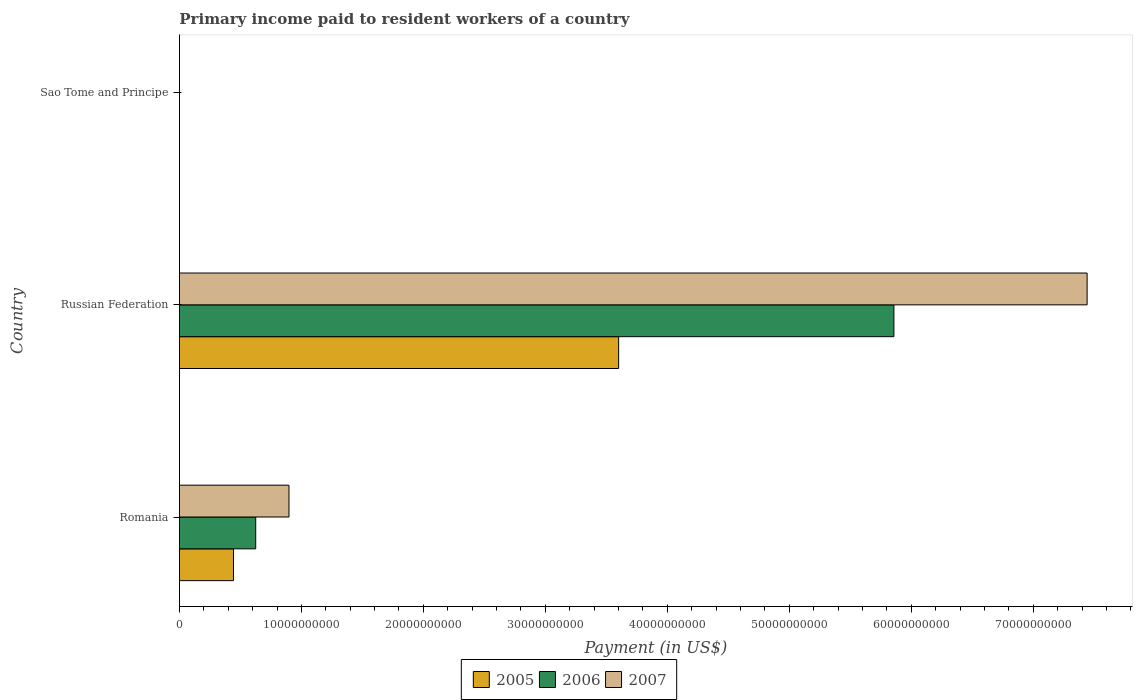Are the number of bars per tick equal to the number of legend labels?
Your response must be concise. Yes. How many bars are there on the 1st tick from the top?
Your answer should be very brief. 3. What is the label of the 3rd group of bars from the top?
Give a very brief answer. Romania. What is the amount paid to workers in 2006 in Russian Federation?
Keep it short and to the point. 5.86e+1. Across all countries, what is the maximum amount paid to workers in 2006?
Your answer should be compact. 5.86e+1. Across all countries, what is the minimum amount paid to workers in 2005?
Provide a succinct answer. 4.90e+06. In which country was the amount paid to workers in 2005 maximum?
Your answer should be very brief. Russian Federation. In which country was the amount paid to workers in 2007 minimum?
Provide a short and direct response. Sao Tome and Principe. What is the total amount paid to workers in 2005 in the graph?
Ensure brevity in your answer.  4.04e+1. What is the difference between the amount paid to workers in 2005 in Romania and that in Sao Tome and Principe?
Your response must be concise. 4.43e+09. What is the difference between the amount paid to workers in 2005 in Romania and the amount paid to workers in 2006 in Sao Tome and Principe?
Offer a terse response. 4.43e+09. What is the average amount paid to workers in 2006 per country?
Give a very brief answer. 2.16e+1. What is the difference between the amount paid to workers in 2006 and amount paid to workers in 2007 in Russian Federation?
Ensure brevity in your answer.  -1.58e+1. In how many countries, is the amount paid to workers in 2005 greater than 68000000000 US$?
Give a very brief answer. 0. What is the ratio of the amount paid to workers in 2007 in Romania to that in Russian Federation?
Your answer should be compact. 0.12. Is the difference between the amount paid to workers in 2006 in Russian Federation and Sao Tome and Principe greater than the difference between the amount paid to workers in 2007 in Russian Federation and Sao Tome and Principe?
Make the answer very short. No. What is the difference between the highest and the second highest amount paid to workers in 2005?
Your response must be concise. 3.16e+1. What is the difference between the highest and the lowest amount paid to workers in 2006?
Your response must be concise. 5.86e+1. Is it the case that in every country, the sum of the amount paid to workers in 2006 and amount paid to workers in 2007 is greater than the amount paid to workers in 2005?
Give a very brief answer. Yes. How many bars are there?
Offer a very short reply. 9. What is the difference between two consecutive major ticks on the X-axis?
Provide a short and direct response. 1.00e+1. Does the graph contain any zero values?
Give a very brief answer. No. Where does the legend appear in the graph?
Ensure brevity in your answer.  Bottom center. How many legend labels are there?
Keep it short and to the point. 3. How are the legend labels stacked?
Offer a very short reply. Horizontal. What is the title of the graph?
Give a very brief answer. Primary income paid to resident workers of a country. Does "1991" appear as one of the legend labels in the graph?
Provide a short and direct response. No. What is the label or title of the X-axis?
Offer a terse response. Payment (in US$). What is the Payment (in US$) of 2005 in Romania?
Provide a short and direct response. 4.43e+09. What is the Payment (in US$) of 2006 in Romania?
Offer a very short reply. 6.26e+09. What is the Payment (in US$) in 2007 in Romania?
Make the answer very short. 8.98e+09. What is the Payment (in US$) in 2005 in Russian Federation?
Ensure brevity in your answer.  3.60e+1. What is the Payment (in US$) in 2006 in Russian Federation?
Your response must be concise. 5.86e+1. What is the Payment (in US$) in 2007 in Russian Federation?
Offer a terse response. 7.44e+1. What is the Payment (in US$) in 2005 in Sao Tome and Principe?
Give a very brief answer. 4.90e+06. What is the Payment (in US$) in 2006 in Sao Tome and Principe?
Provide a succinct answer. 3.12e+06. What is the Payment (in US$) in 2007 in Sao Tome and Principe?
Offer a terse response. 2.29e+06. Across all countries, what is the maximum Payment (in US$) of 2005?
Keep it short and to the point. 3.60e+1. Across all countries, what is the maximum Payment (in US$) of 2006?
Provide a short and direct response. 5.86e+1. Across all countries, what is the maximum Payment (in US$) in 2007?
Provide a short and direct response. 7.44e+1. Across all countries, what is the minimum Payment (in US$) in 2005?
Provide a succinct answer. 4.90e+06. Across all countries, what is the minimum Payment (in US$) in 2006?
Offer a terse response. 3.12e+06. Across all countries, what is the minimum Payment (in US$) of 2007?
Offer a very short reply. 2.29e+06. What is the total Payment (in US$) of 2005 in the graph?
Provide a succinct answer. 4.04e+1. What is the total Payment (in US$) in 2006 in the graph?
Your answer should be compact. 6.48e+1. What is the total Payment (in US$) in 2007 in the graph?
Offer a very short reply. 8.34e+1. What is the difference between the Payment (in US$) of 2005 in Romania and that in Russian Federation?
Make the answer very short. -3.16e+1. What is the difference between the Payment (in US$) of 2006 in Romania and that in Russian Federation?
Give a very brief answer. -5.23e+1. What is the difference between the Payment (in US$) of 2007 in Romania and that in Russian Federation?
Make the answer very short. -6.54e+1. What is the difference between the Payment (in US$) in 2005 in Romania and that in Sao Tome and Principe?
Provide a short and direct response. 4.43e+09. What is the difference between the Payment (in US$) of 2006 in Romania and that in Sao Tome and Principe?
Your response must be concise. 6.25e+09. What is the difference between the Payment (in US$) of 2007 in Romania and that in Sao Tome and Principe?
Your response must be concise. 8.98e+09. What is the difference between the Payment (in US$) in 2005 in Russian Federation and that in Sao Tome and Principe?
Give a very brief answer. 3.60e+1. What is the difference between the Payment (in US$) in 2006 in Russian Federation and that in Sao Tome and Principe?
Your answer should be compact. 5.86e+1. What is the difference between the Payment (in US$) of 2007 in Russian Federation and that in Sao Tome and Principe?
Provide a succinct answer. 7.44e+1. What is the difference between the Payment (in US$) in 2005 in Romania and the Payment (in US$) in 2006 in Russian Federation?
Offer a very short reply. -5.41e+1. What is the difference between the Payment (in US$) of 2005 in Romania and the Payment (in US$) of 2007 in Russian Federation?
Keep it short and to the point. -7.00e+1. What is the difference between the Payment (in US$) of 2006 in Romania and the Payment (in US$) of 2007 in Russian Federation?
Your answer should be very brief. -6.82e+1. What is the difference between the Payment (in US$) of 2005 in Romania and the Payment (in US$) of 2006 in Sao Tome and Principe?
Provide a short and direct response. 4.43e+09. What is the difference between the Payment (in US$) of 2005 in Romania and the Payment (in US$) of 2007 in Sao Tome and Principe?
Make the answer very short. 4.43e+09. What is the difference between the Payment (in US$) in 2006 in Romania and the Payment (in US$) in 2007 in Sao Tome and Principe?
Give a very brief answer. 6.25e+09. What is the difference between the Payment (in US$) in 2005 in Russian Federation and the Payment (in US$) in 2006 in Sao Tome and Principe?
Your answer should be very brief. 3.60e+1. What is the difference between the Payment (in US$) of 2005 in Russian Federation and the Payment (in US$) of 2007 in Sao Tome and Principe?
Provide a succinct answer. 3.60e+1. What is the difference between the Payment (in US$) in 2006 in Russian Federation and the Payment (in US$) in 2007 in Sao Tome and Principe?
Your response must be concise. 5.86e+1. What is the average Payment (in US$) of 2005 per country?
Your response must be concise. 1.35e+1. What is the average Payment (in US$) in 2006 per country?
Give a very brief answer. 2.16e+1. What is the average Payment (in US$) in 2007 per country?
Make the answer very short. 2.78e+1. What is the difference between the Payment (in US$) of 2005 and Payment (in US$) of 2006 in Romania?
Your answer should be very brief. -1.82e+09. What is the difference between the Payment (in US$) in 2005 and Payment (in US$) in 2007 in Romania?
Provide a succinct answer. -4.55e+09. What is the difference between the Payment (in US$) of 2006 and Payment (in US$) of 2007 in Romania?
Make the answer very short. -2.73e+09. What is the difference between the Payment (in US$) in 2005 and Payment (in US$) in 2006 in Russian Federation?
Your answer should be very brief. -2.26e+1. What is the difference between the Payment (in US$) in 2005 and Payment (in US$) in 2007 in Russian Federation?
Your answer should be very brief. -3.84e+1. What is the difference between the Payment (in US$) in 2006 and Payment (in US$) in 2007 in Russian Federation?
Offer a terse response. -1.58e+1. What is the difference between the Payment (in US$) in 2005 and Payment (in US$) in 2006 in Sao Tome and Principe?
Your answer should be very brief. 1.78e+06. What is the difference between the Payment (in US$) of 2005 and Payment (in US$) of 2007 in Sao Tome and Principe?
Provide a succinct answer. 2.61e+06. What is the difference between the Payment (in US$) of 2006 and Payment (in US$) of 2007 in Sao Tome and Principe?
Provide a short and direct response. 8.31e+05. What is the ratio of the Payment (in US$) in 2005 in Romania to that in Russian Federation?
Your answer should be compact. 0.12. What is the ratio of the Payment (in US$) of 2006 in Romania to that in Russian Federation?
Make the answer very short. 0.11. What is the ratio of the Payment (in US$) of 2007 in Romania to that in Russian Federation?
Make the answer very short. 0.12. What is the ratio of the Payment (in US$) of 2005 in Romania to that in Sao Tome and Principe?
Your answer should be compact. 905.04. What is the ratio of the Payment (in US$) in 2006 in Romania to that in Sao Tome and Principe?
Offer a terse response. 2004.32. What is the ratio of the Payment (in US$) of 2007 in Romania to that in Sao Tome and Principe?
Your response must be concise. 3922.77. What is the ratio of the Payment (in US$) in 2005 in Russian Federation to that in Sao Tome and Principe?
Provide a succinct answer. 7352.32. What is the ratio of the Payment (in US$) in 2006 in Russian Federation to that in Sao Tome and Principe?
Offer a very short reply. 1.88e+04. What is the ratio of the Payment (in US$) of 2007 in Russian Federation to that in Sao Tome and Principe?
Make the answer very short. 3.25e+04. What is the difference between the highest and the second highest Payment (in US$) of 2005?
Offer a terse response. 3.16e+1. What is the difference between the highest and the second highest Payment (in US$) in 2006?
Ensure brevity in your answer.  5.23e+1. What is the difference between the highest and the second highest Payment (in US$) of 2007?
Your response must be concise. 6.54e+1. What is the difference between the highest and the lowest Payment (in US$) in 2005?
Offer a terse response. 3.60e+1. What is the difference between the highest and the lowest Payment (in US$) in 2006?
Offer a terse response. 5.86e+1. What is the difference between the highest and the lowest Payment (in US$) of 2007?
Your answer should be very brief. 7.44e+1. 